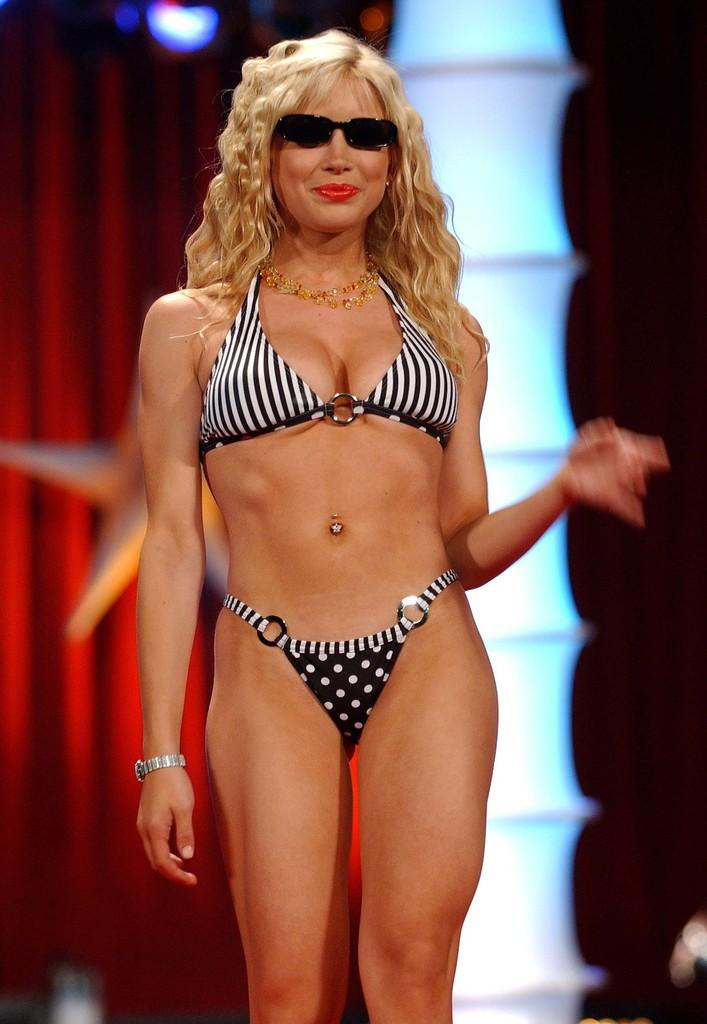Who is the main subject in the image? There is a woman in the image. Where is the woman located in the image? The woman is standing on a stage. What accessory is the woman wearing in the image? The woman is wearing spectacles. What can be seen in the background of the image? There is a red color curtain in the background of the image. How many cherries are on the woman's head in the image? There are no cherries present on the woman's head in the image. What type of heart-shaped object can be seen in the image? There is no heart-shaped object present in the image. 